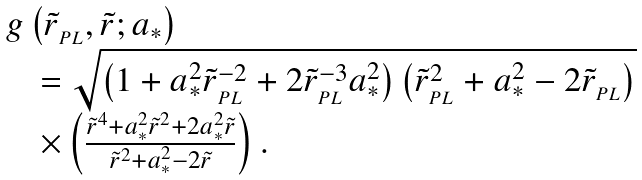<formula> <loc_0><loc_0><loc_500><loc_500>\begin{array} { l } g \left ( { \tilde { r } _ { _ { P L } } , \tilde { r } ; a _ { * } } \right ) \\ \quad = \sqrt { \left ( { 1 + a _ { * } ^ { 2 } \tilde { r } _ { _ { P L } } ^ { - 2 } + 2 \tilde { r } _ { _ { P L } } ^ { - 3 } a _ { * } ^ { 2 } } \right ) \left ( { \tilde { r } _ { _ { P L } } ^ { 2 } + a _ { * } ^ { 2 } - 2 \tilde { r } _ { _ { P L } } } \right ) } \\ \quad \times \left ( { \frac { \tilde { r } ^ { 4 } + a _ { * } ^ { 2 } \tilde { r } ^ { 2 } + 2 a _ { * } ^ { 2 } \tilde { r } } { \tilde { r } ^ { 2 } + a _ { * } ^ { 2 } - 2 \tilde { r } } } \right ) . \end{array}</formula> 